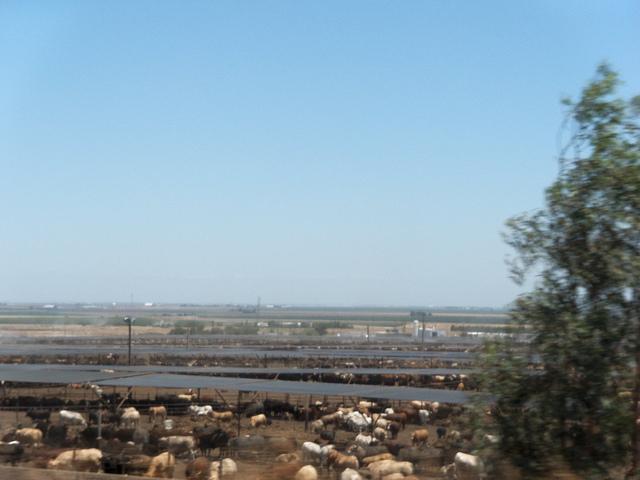What danger does the fence at the back of the lot protect the cows from?
Make your selection from the four choices given to correctly answer the question.
Options: Dehydration, insects, drowning, starving. Drowning. 